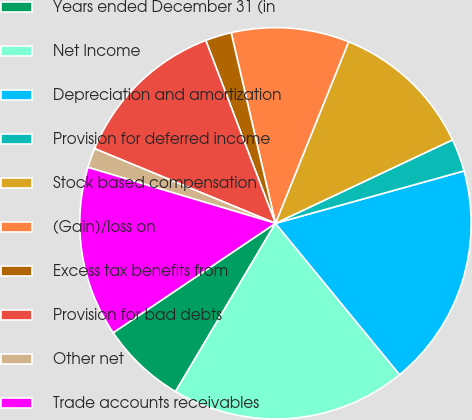Convert chart. <chart><loc_0><loc_0><loc_500><loc_500><pie_chart><fcel>Years ended December 31 (in<fcel>Net Income<fcel>Depreciation and amortization<fcel>Provision for deferred income<fcel>Stock based compensation<fcel>(Gain)/loss on<fcel>Excess tax benefits from<fcel>Provision for bad debts<fcel>Other net<fcel>Trade accounts receivables<nl><fcel>7.03%<fcel>19.46%<fcel>18.38%<fcel>2.7%<fcel>11.89%<fcel>9.73%<fcel>2.16%<fcel>12.97%<fcel>1.62%<fcel>14.05%<nl></chart> 